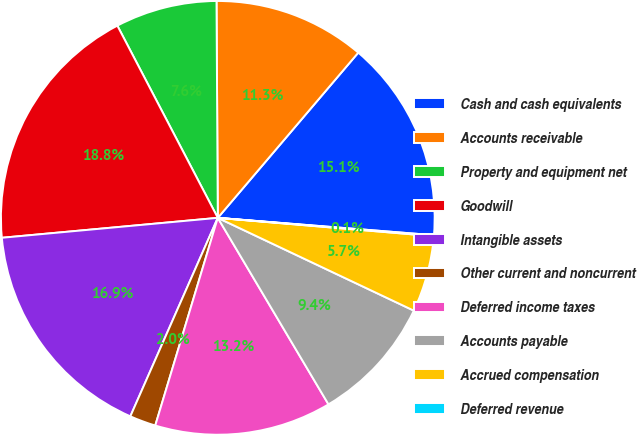<chart> <loc_0><loc_0><loc_500><loc_500><pie_chart><fcel>Cash and cash equivalents<fcel>Accounts receivable<fcel>Property and equipment net<fcel>Goodwill<fcel>Intangible assets<fcel>Other current and noncurrent<fcel>Deferred income taxes<fcel>Accounts payable<fcel>Accrued compensation<fcel>Deferred revenue<nl><fcel>15.06%<fcel>11.31%<fcel>7.57%<fcel>18.8%<fcel>16.93%<fcel>1.95%<fcel>13.18%<fcel>9.44%<fcel>5.69%<fcel>0.07%<nl></chart> 